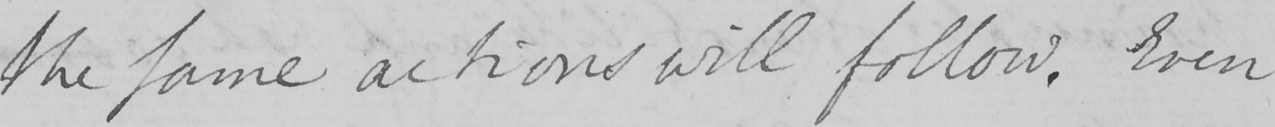Please provide the text content of this handwritten line. the same actions will follow . Even 